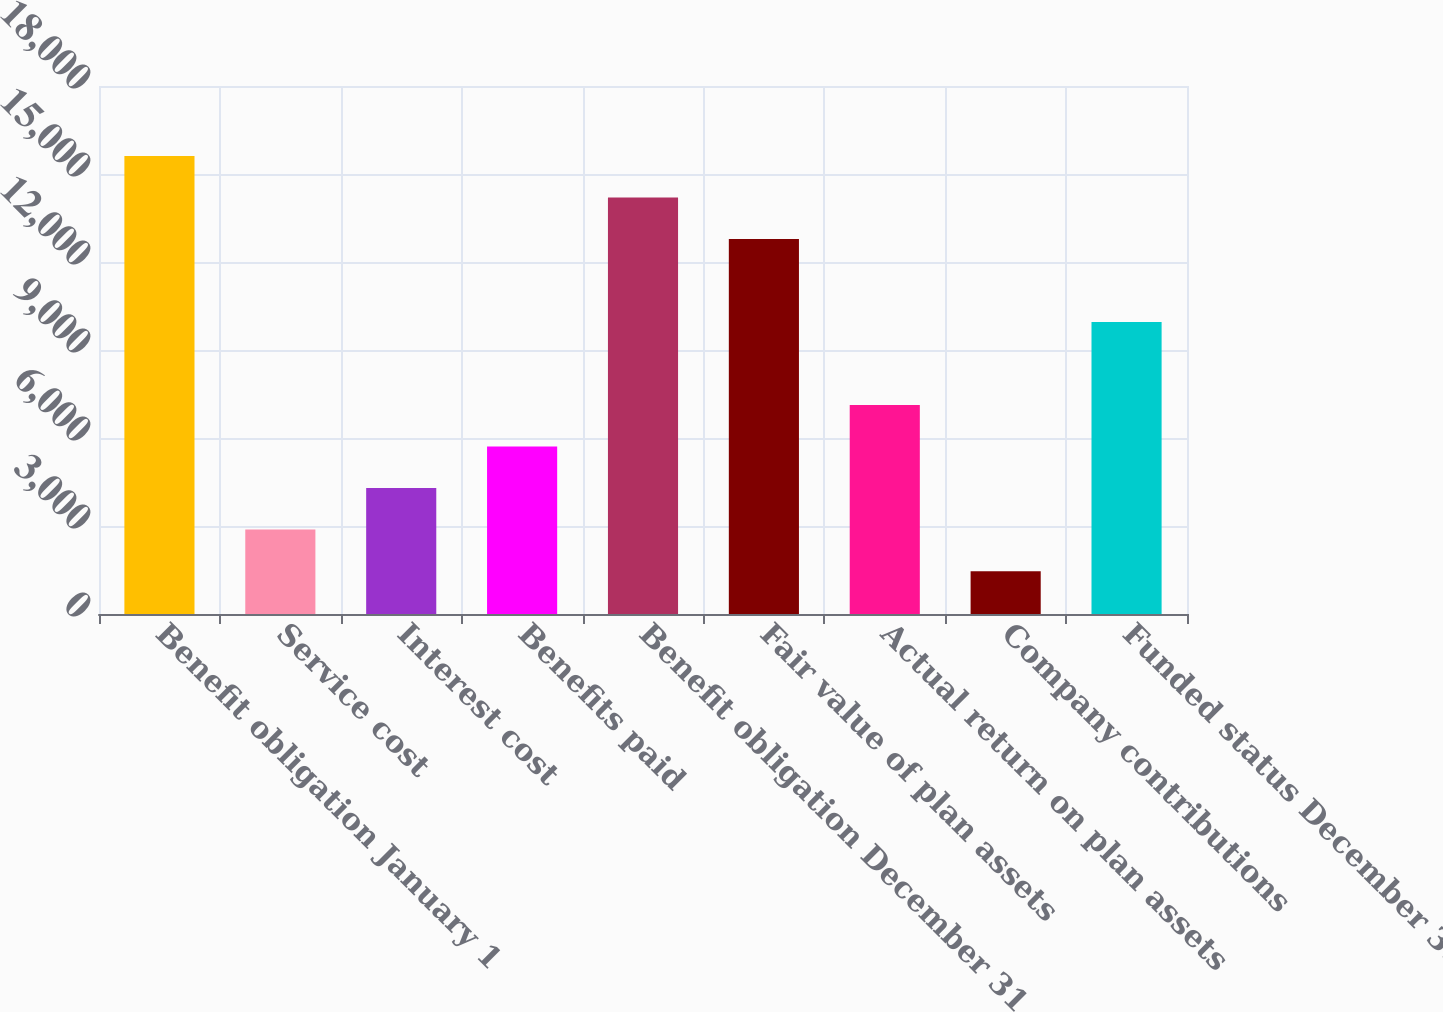Convert chart to OTSL. <chart><loc_0><loc_0><loc_500><loc_500><bar_chart><fcel>Benefit obligation January 1<fcel>Service cost<fcel>Interest cost<fcel>Benefits paid<fcel>Benefit obligation December 31<fcel>Fair value of plan assets<fcel>Actual return on plan assets<fcel>Company contributions<fcel>Funded status December 31<nl><fcel>15616.5<fcel>2877<fcel>4292.5<fcel>5708<fcel>14201<fcel>12785.5<fcel>7123.5<fcel>1461.5<fcel>9954.5<nl></chart> 